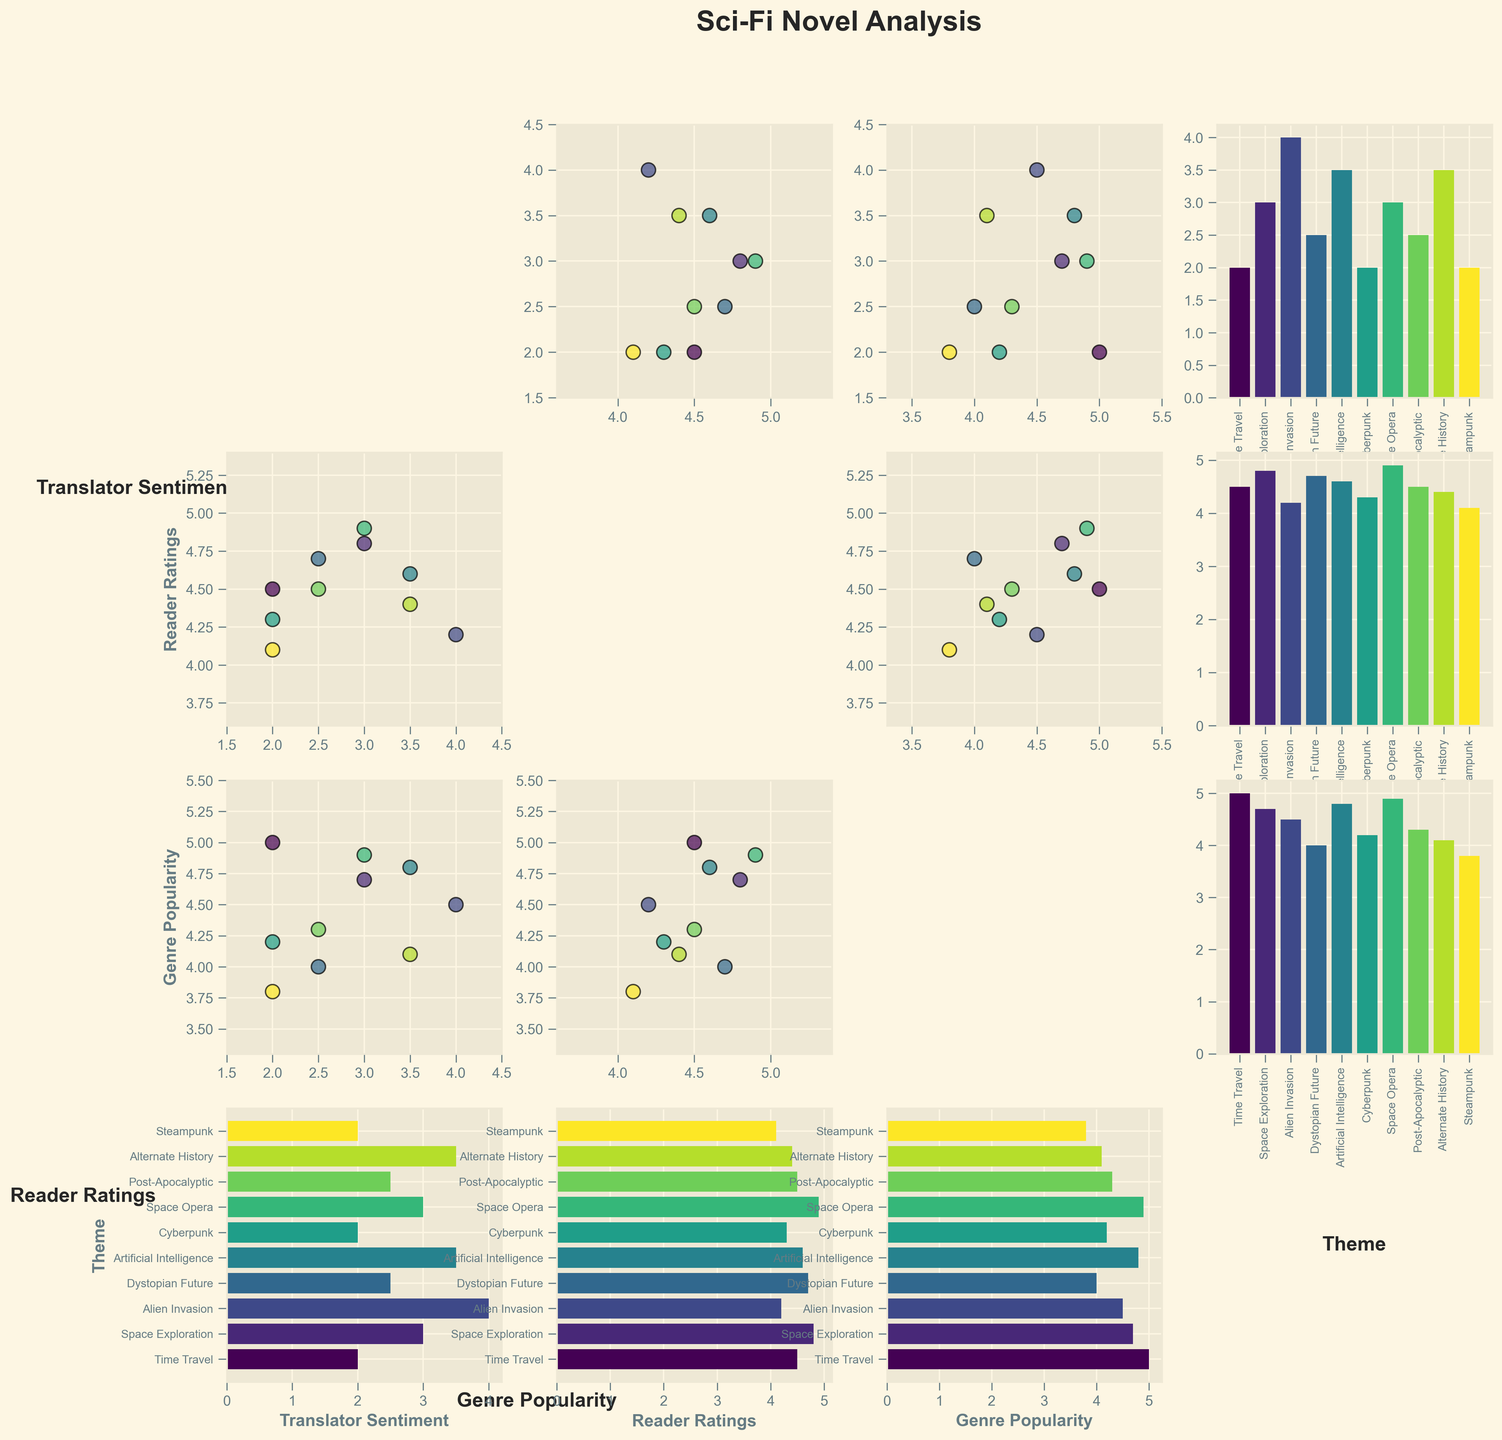What's the title of the plot? The title of the plot is displayed at the top center of the figure. It is written in bold and large font size.
Answer: Sci-Fi Novel Analysis How many themes are evaluated in the plot? The themes can be counted by looking at the labels along the "Theme" column or row, where individual themes are listed.
Answer: 10 Do Translator Sentiment and Reader Ratings have any negative correlation? We can see if there are more points sloping downward in the scatter plot between Translator Sentiment and Reader Ratings. However, from visual inspection, most points trend horizontally or upward.
Answer: No Which theme has the highest Genre Popularity? The bar plots related to Genre Popularity on the "Theme" row will show the highest bar. Visual inspection reveals that Space Opera has the highest bar in the Genre Popularity category.
Answer: Space Opera Is there clustering among Reader Ratings based on Translator Sentiment? By examining the scatter plot with Reader Ratings on the x-axis and Translator Sentiment on the y-axis, we can observe the spread and density of points. The points seem evenly spread out without clear clustering patterns.
Answer: No Which two themes have the closest Translator Sentiment values? We need to find themes with similar bar heights in the Translator Sentiment bar plot on the "Theme" column. Time Travel and Cyberpunk both have a Translator Sentiment of 2.
Answer: Time Travel and Cyberpunk What's the average Reader Rating for Time Travel and Space Exploration? The Reader Ratings are 4.5 for Time Travel and 4.8 for Space Exploration. Average them: (4.5 + 4.8) / 2 = 4.65.
Answer: 4.65 Which theme has a higher Translator Sentiment: Steampunk or Alternate History? By comparing the bars in the Translator Sentiment bar plot for Steampunk and Alternate History, Steampunk's bar is lower than Alternate History's.
Answer: Alternate History How do you identify the theme with the lowest Reader Rating? Look for the shortest bar in the Reader Ratings bar plot on the "Theme" row. Steampunk has the shortest bar (4.1).
Answer: Steampunk Are there any themes where the Genre Popularity is exactly equal to 4.5? Scan the bars in the Genre Popularity bar plot to see if any hit exactly 4.5. Alien Invasion has a Genre Popularity value of 4.5.
Answer: Alien Invasion 